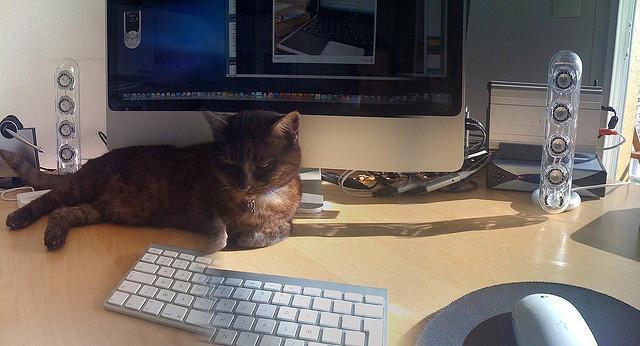How many elephant tails are showing?
Give a very brief answer. 0. 